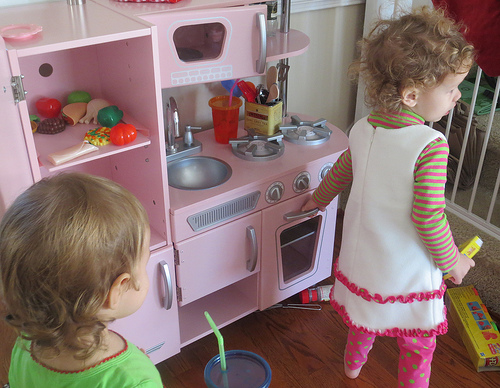<image>
Can you confirm if the girl is to the left of the girl? No. The girl is not to the left of the girl. From this viewpoint, they have a different horizontal relationship. 